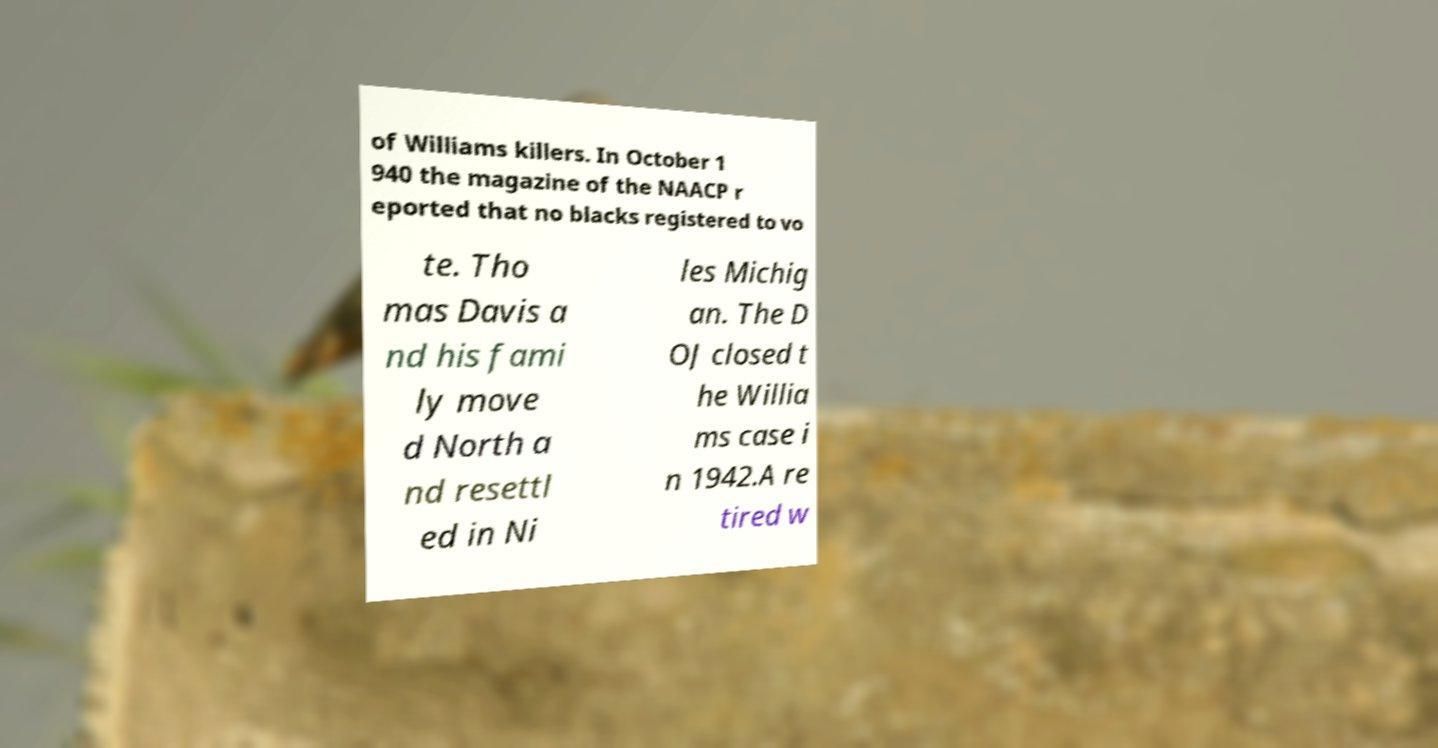Can you read and provide the text displayed in the image?This photo seems to have some interesting text. Can you extract and type it out for me? of Williams killers. In October 1 940 the magazine of the NAACP r eported that no blacks registered to vo te. Tho mas Davis a nd his fami ly move d North a nd resettl ed in Ni les Michig an. The D OJ closed t he Willia ms case i n 1942.A re tired w 